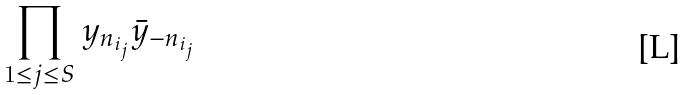Convert formula to latex. <formula><loc_0><loc_0><loc_500><loc_500>\prod _ { 1 \leq j \leq S } y _ { n _ { i _ { j } } } \bar { y } _ { - n _ { i _ { j } } }</formula> 